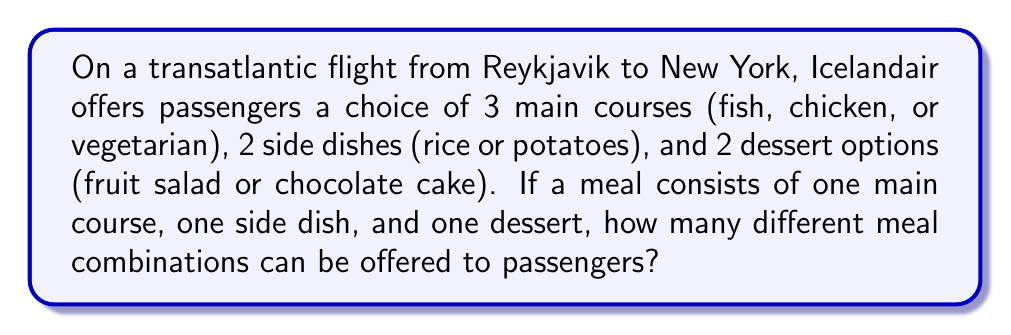Show me your answer to this math problem. Let's break this down step-by-step using the multiplication principle of counting:

1) For the main course, there are 3 choices.

2) For each main course, there are 2 choices of side dishes.

3) For each combination of main course and side dish, there are 2 choices of dessert.

Therefore, we can calculate the total number of meal combinations as follows:

$$ \text{Total combinations} = \text{(Main courses)} \times \text{(Side dishes)} \times \text{(Desserts)} $$

$$ = 3 \times 2 \times 2 $$

$$ = 12 $$

We can also think of this as a tree diagram with 3 branches for main courses, each splitting into 2 branches for side dishes, and each of those splitting into 2 branches for desserts. The number of end points on this tree would be 12.

Alternatively, we could list out all possibilities:
1. Fish, Rice, Fruit Salad
2. Fish, Rice, Chocolate Cake
3. Fish, Potatoes, Fruit Salad
4. Fish, Potatoes, Chocolate Cake
5. Chicken, Rice, Fruit Salad
6. Chicken, Rice, Chocolate Cake
7. Chicken, Potatoes, Fruit Salad
8. Chicken, Potatoes, Chocolate Cake
9. Vegetarian, Rice, Fruit Salad
10. Vegetarian, Rice, Chocolate Cake
11. Vegetarian, Potatoes, Fruit Salad
12. Vegetarian, Potatoes, Chocolate Cake

This confirms our calculation of 12 different meal combinations.
Answer: 12 combinations 